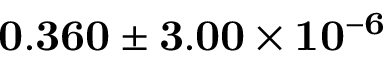Convert formula to latex. <formula><loc_0><loc_0><loc_500><loc_500>0 . 3 6 0 \pm 3 . 0 0 \times 1 0 ^ { - 6 }</formula> 